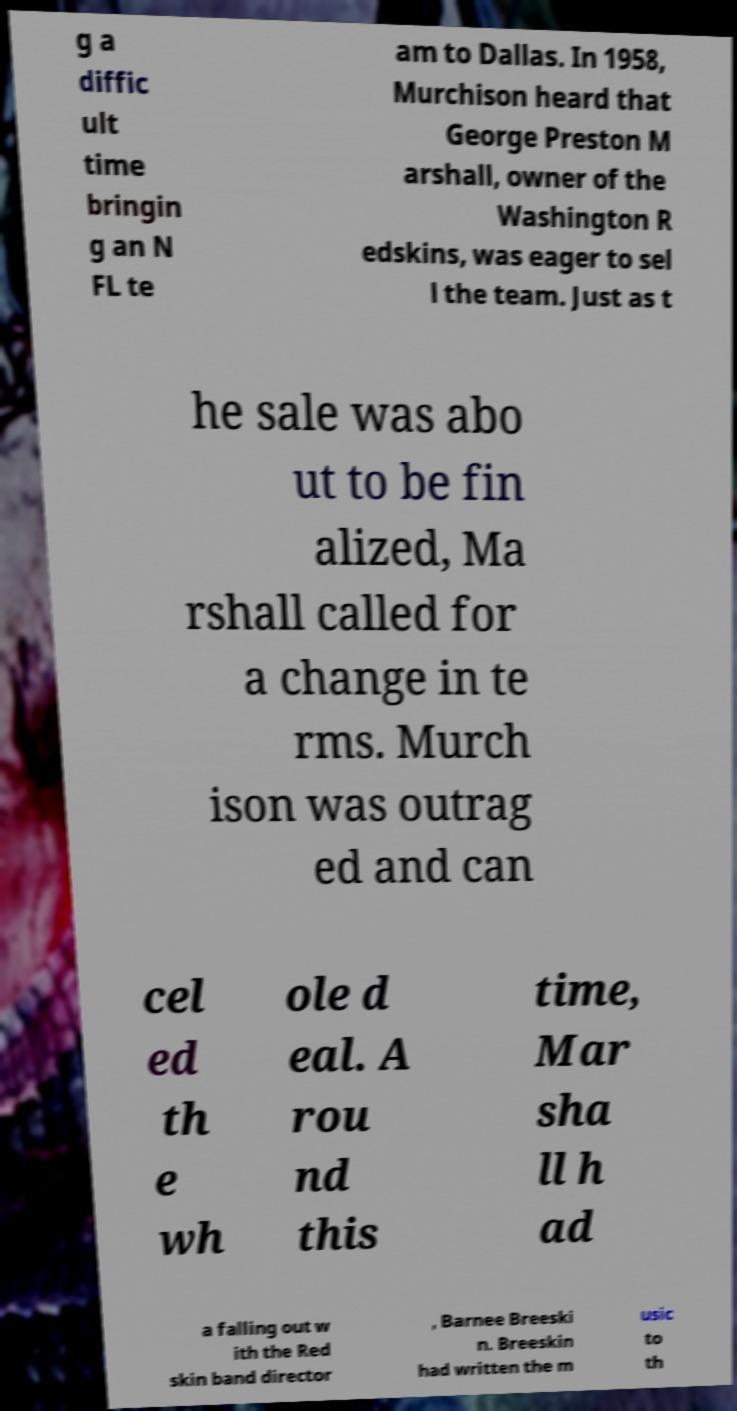Could you assist in decoding the text presented in this image and type it out clearly? g a diffic ult time bringin g an N FL te am to Dallas. In 1958, Murchison heard that George Preston M arshall, owner of the Washington R edskins, was eager to sel l the team. Just as t he sale was abo ut to be fin alized, Ma rshall called for a change in te rms. Murch ison was outrag ed and can cel ed th e wh ole d eal. A rou nd this time, Mar sha ll h ad a falling out w ith the Red skin band director , Barnee Breeski n. Breeskin had written the m usic to th 